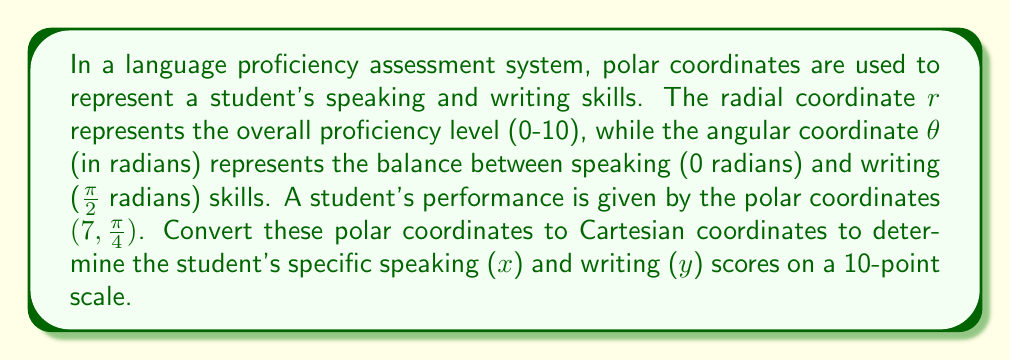Teach me how to tackle this problem. To convert polar coordinates $(r, \theta)$ to Cartesian coordinates $(x, y)$, we use the following formulas:

$$x = r \cos(\theta)$$
$$y = r \sin(\theta)$$

Given:
$r = 7$ (overall proficiency level)
$\theta = \frac{\pi}{4}$ (balance between speaking and writing skills)

Step 1: Calculate the x-coordinate (speaking score)
$$x = r \cos(\theta) = 7 \cos(\frac{\pi}{4})$$

We know that $\cos(\frac{\pi}{4}) = \frac{\sqrt{2}}{2}$, so:

$$x = 7 \cdot \frac{\sqrt{2}}{2} = \frac{7\sqrt{2}}{2} \approx 4.95$$

Step 2: Calculate the y-coordinate (writing score)
$$y = r \sin(\theta) = 7 \sin(\frac{\pi}{4})$$

We know that $\sin(\frac{\pi}{4}) = \frac{\sqrt{2}}{2}$, so:

$$y = 7 \cdot \frac{\sqrt{2}}{2} = \frac{7\sqrt{2}}{2} \approx 4.95$$

Therefore, the student's speaking score (x) and writing score (y) are both approximately 4.95 on a 10-point scale.
Answer: The Cartesian coordinates are $(\frac{7\sqrt{2}}{2}, \frac{7\sqrt{2}}{2})$, or approximately $(4.95, 4.95)$ on a 10-point scale. 